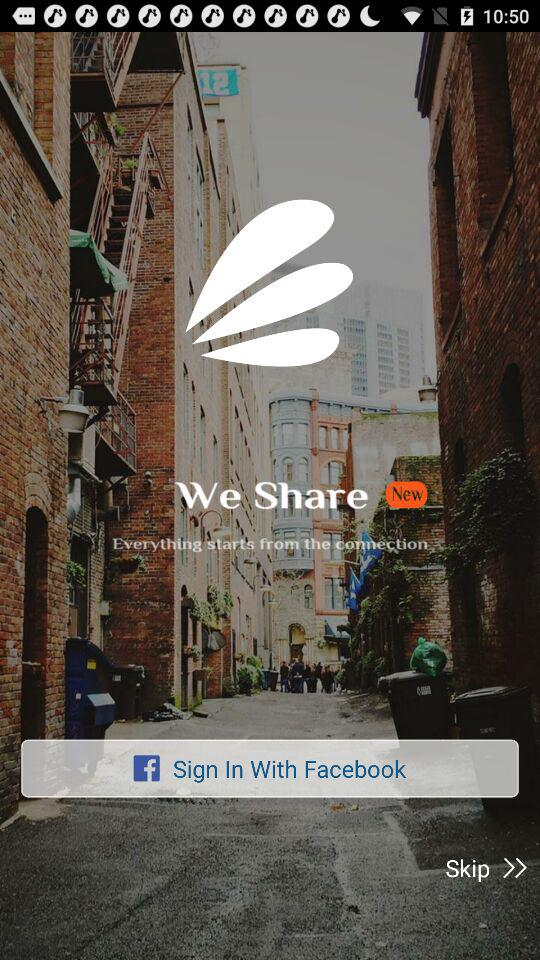What is the application name? The application name is "We Share". 